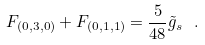<formula> <loc_0><loc_0><loc_500><loc_500>F _ { ( 0 , 3 , 0 ) } + F _ { ( 0 , 1 , 1 ) } = \frac { 5 } { 4 8 } { \tilde { g } } _ { s } \ . \label l { e q \colon t h r e e s t r i n g a n d m o r e }</formula> 